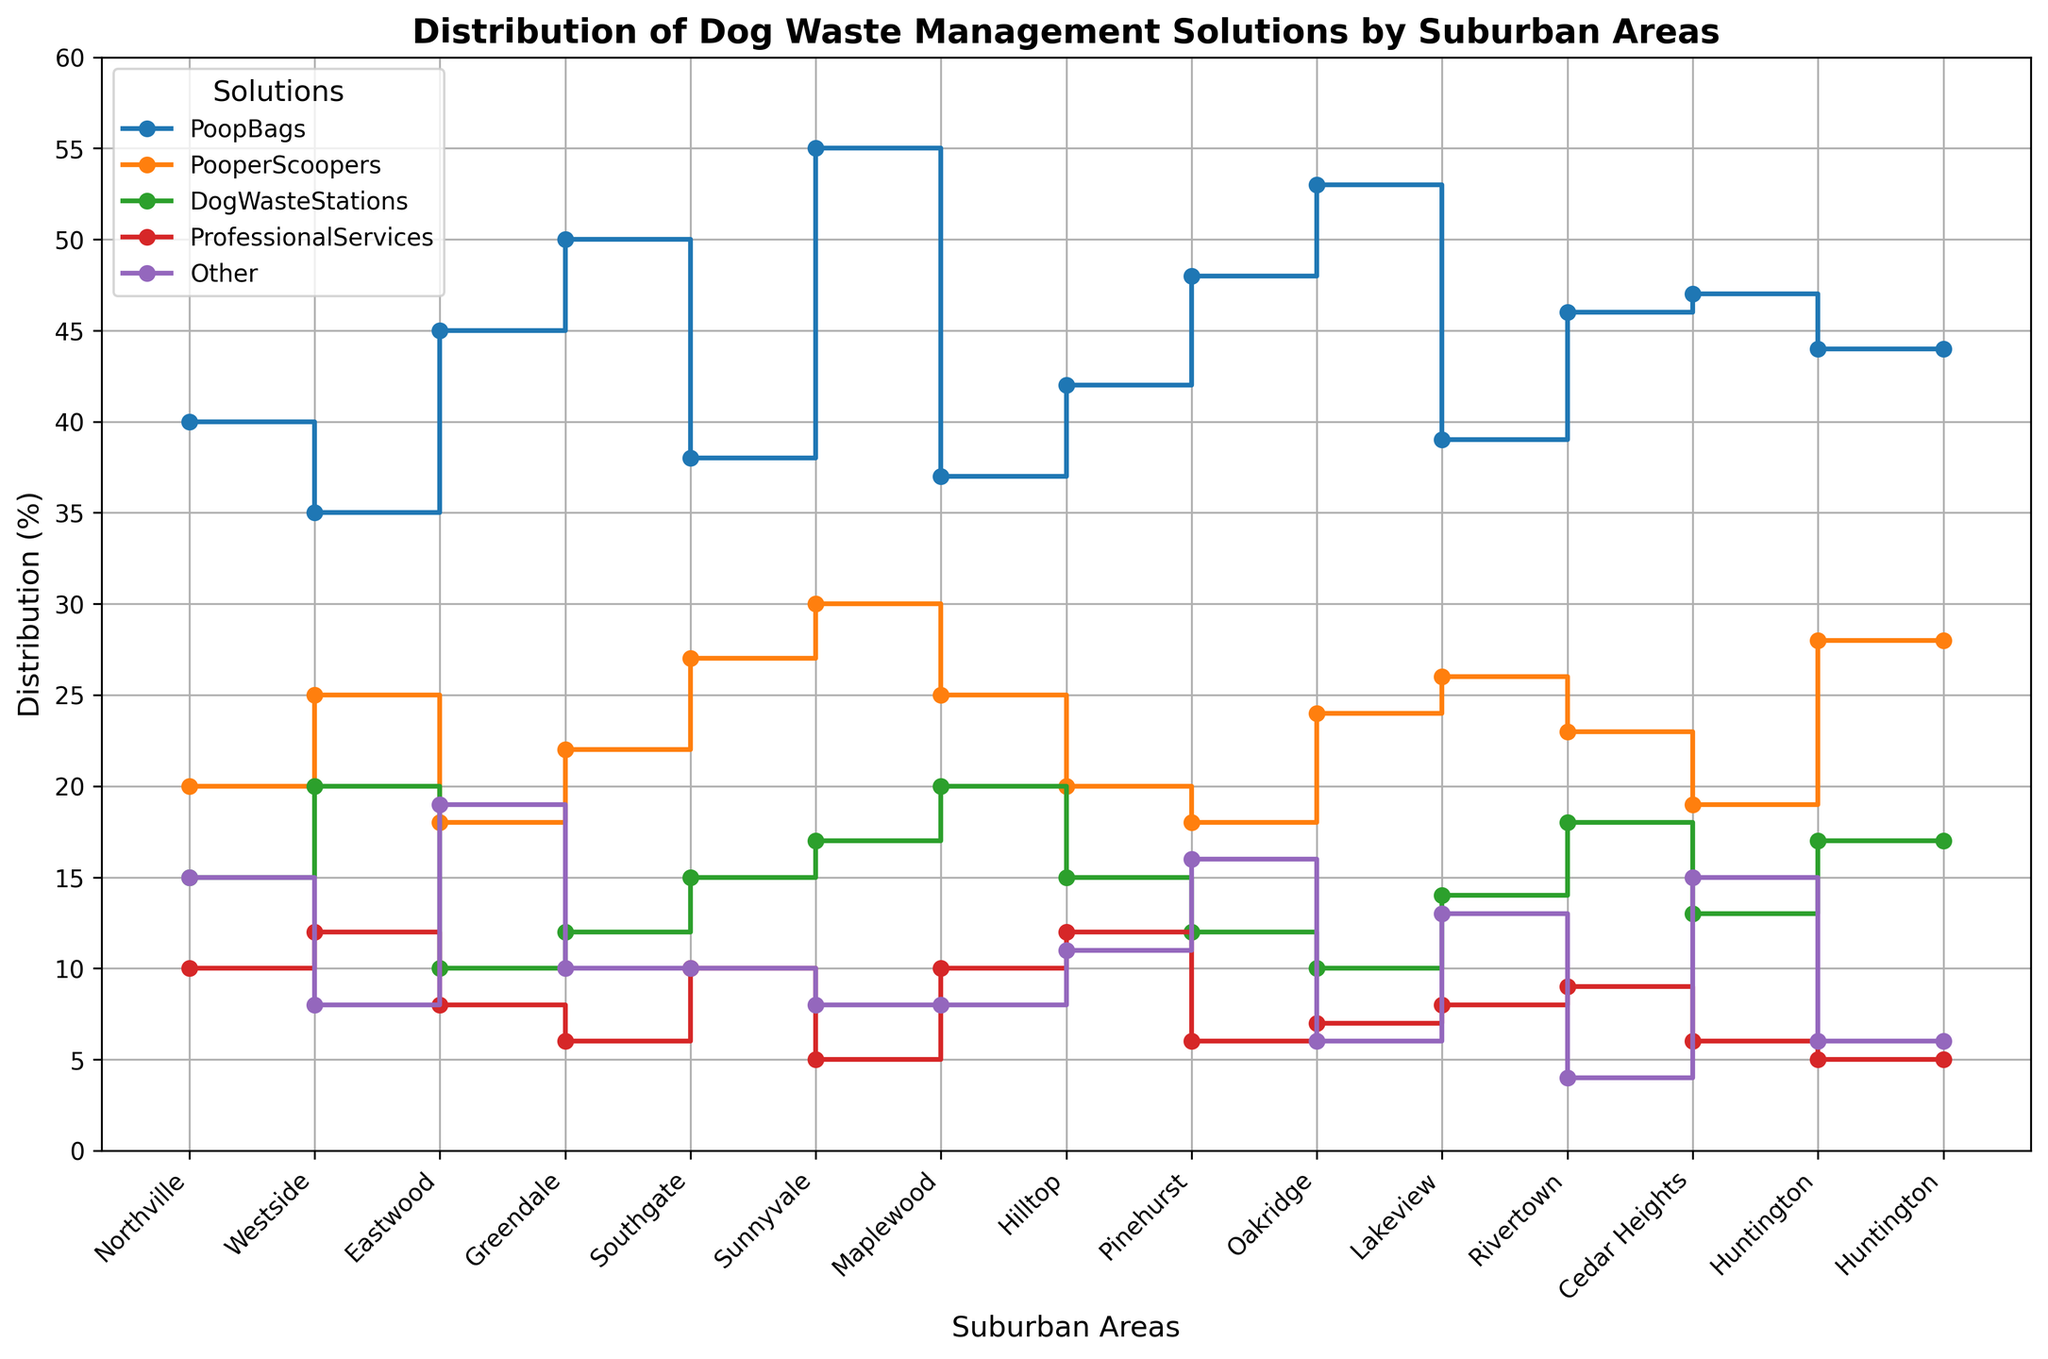Which suburban area uses the most professional services for dog waste management? In the plot, locate the line for 'ProfessionalServices' (usually marked in red) and identify the suburban area at the peak of this line.
Answer: Sunnyvale Which suburban area has the lowest proportion of dog waste management using 'DogWasteStations'? Trace the step line for 'DogWasteStations' (marked probably in green) and find the suburban area at the lowest step.
Answer: Eastwood Between 'Greendale' and 'Hilltop,' which area has a higher distribution percentage for 'PoopBags'? Compare the heights of the 'PoopBags' step lines (marked possibly in blue) for 'Greendale' and 'Hilltop'.
Answer: Greendale What's the combined percentage for 'PoopBags' and 'PooperScoopers' in Eastwood? Find the 'PoopBags' percentage (45%) and the 'PooperScoopers' percentage (18%) in Eastwood, then add them together: 45 + 18.
Answer: 63% Is there any suburban area where 'PoopBags' and 'Other' have the same distribution percentage? Compare the 'PoopBags' and 'Other' step lines for equal heights across all suburban areas.
Answer: No Which solution type has the most consistent distribution percentage across different suburban areas? Evaluate the step lines and see which one has the least variance or changes the least between suburban areas.
Answer: PoopBags Of the two, Southgate or Oakridge, which one has a higher percentage for 'ProfessionalServices'? Compare the 'ProfessionalServices' step lines (marked possibly in red) for Southgate and Oakridge.
Answer: Southgate What's the average percentage of 'PooperScoopers' across all suburban areas? Sum the percentages for 'PooperScoopers' in each suburban area (20 + 25 + 18 + 22 + 27 + 30 + 25 + 20 + 18 + 24 + 26 + 23 + 19 + 28 = 325), then divide by the number of suburban areas (14): 325/14.
Answer: 23.2% Between 'Lakeview' and 'Rivertown,' which area has more diverse solutions (i.e., greater spread between minimum and maximum usage)? Compare the ranges for each solution type ('PoopBags', 'PooperScoopers', 'DogWasteStations', 'ProfessionalServices', 'Other') in Lakeview and Rivertown to determine the spread.
Answer: Lakeview 